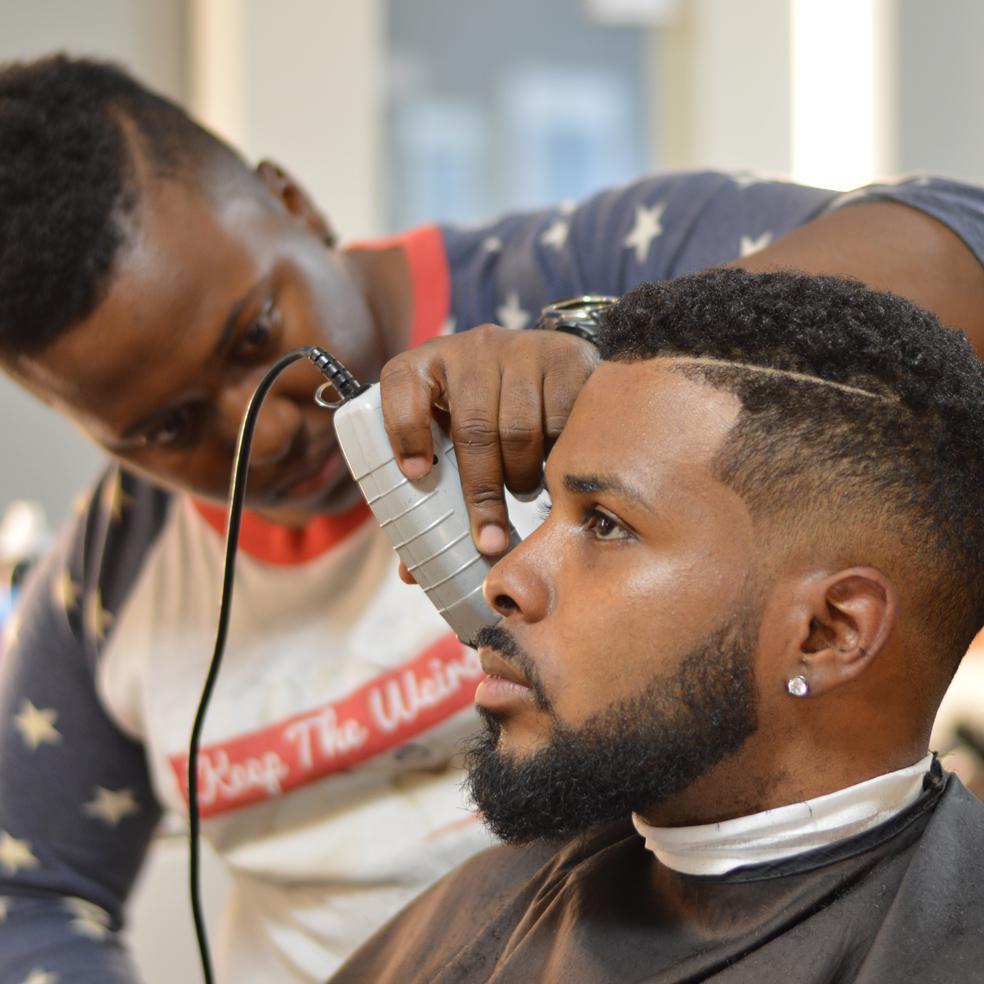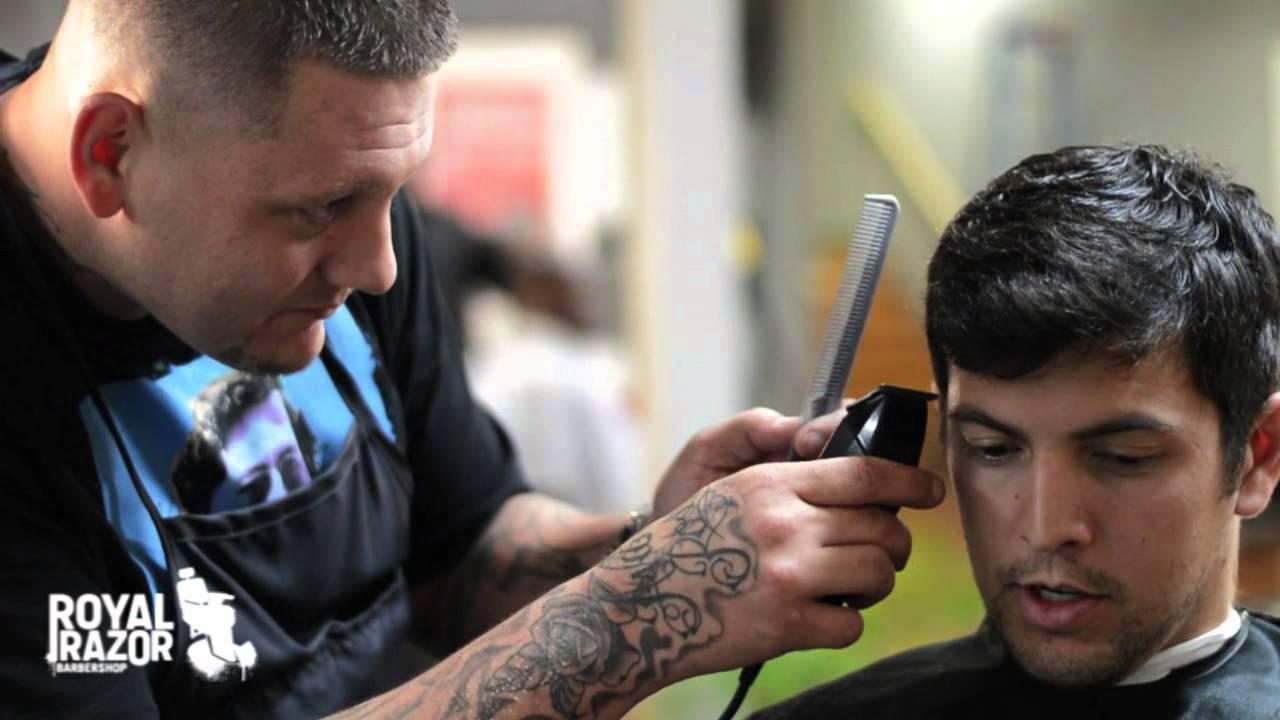The first image is the image on the left, the second image is the image on the right. Analyze the images presented: Is the assertion "There are three barbers in total." valid? Answer yes or no. No. The first image is the image on the left, the second image is the image on the right. Analyze the images presented: Is the assertion "There are exactly four people." valid? Answer yes or no. Yes. 